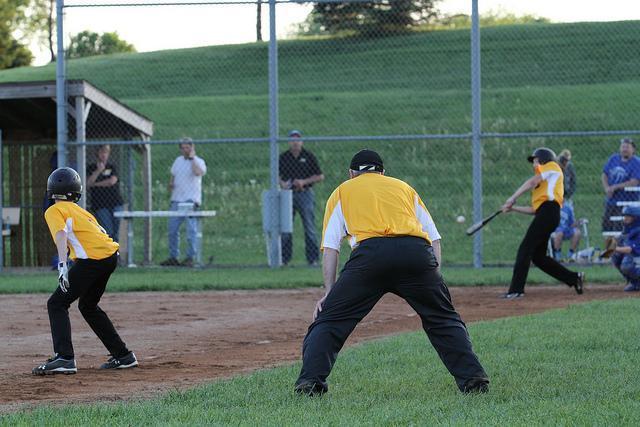How many people are visible?
Give a very brief answer. 7. How many giraffes are in this image?
Give a very brief answer. 0. 